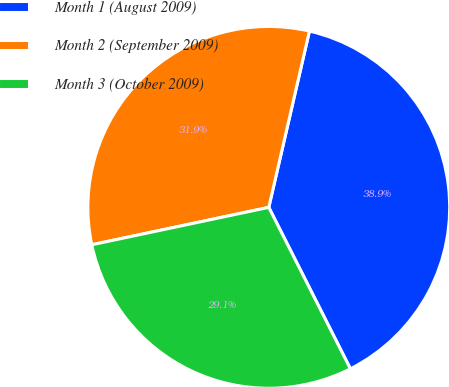<chart> <loc_0><loc_0><loc_500><loc_500><pie_chart><fcel>Month 1 (August 2009)<fcel>Month 2 (September 2009)<fcel>Month 3 (October 2009)<nl><fcel>38.94%<fcel>31.92%<fcel>29.13%<nl></chart> 